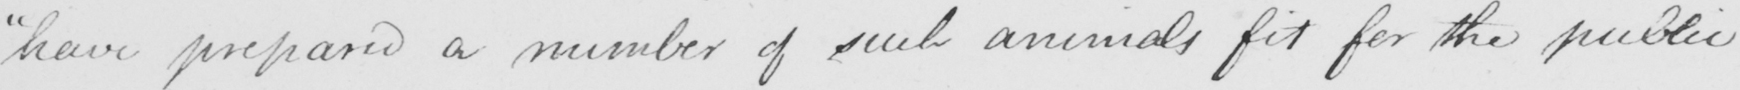Can you tell me what this handwritten text says? "have prepared a number of such animals fit for the public 